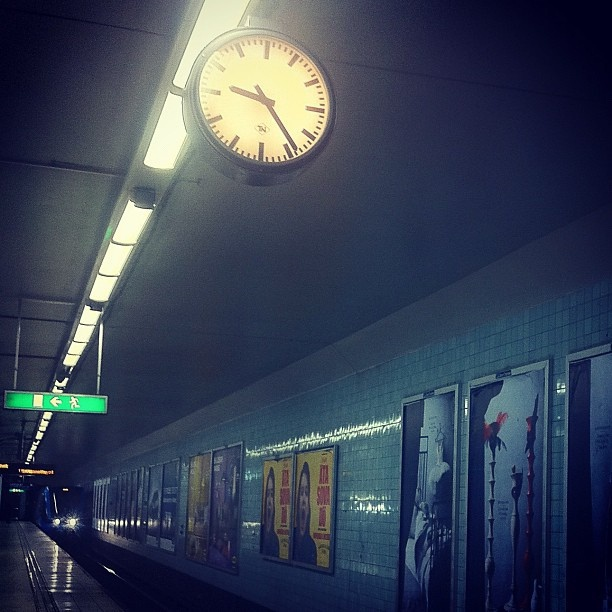Describe the objects in this image and their specific colors. I can see train in black, navy, blue, and gray tones, clock in black, khaki, lightyellow, gray, and tan tones, and train in black, navy, gray, and beige tones in this image. 